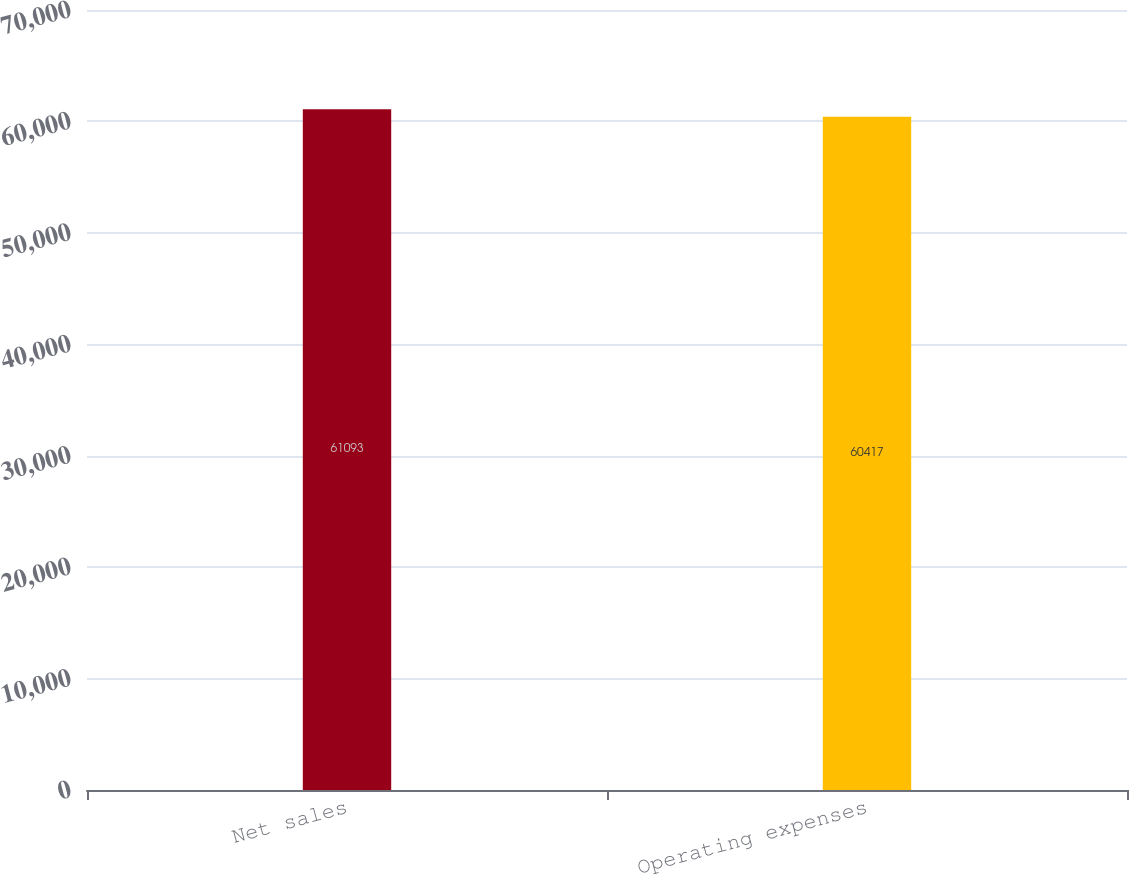Convert chart. <chart><loc_0><loc_0><loc_500><loc_500><bar_chart><fcel>Net sales<fcel>Operating expenses<nl><fcel>61093<fcel>60417<nl></chart> 